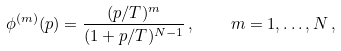<formula> <loc_0><loc_0><loc_500><loc_500>\phi ^ { ( m ) } ( p ) = \frac { ( p / T ) ^ { m } } { ( 1 + p / T ) ^ { N - 1 } } \, , \quad m = 1 , \dots , N \, ,</formula> 